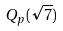Convert formula to latex. <formula><loc_0><loc_0><loc_500><loc_500>Q _ { p } ( \sqrt { 7 } )</formula> 